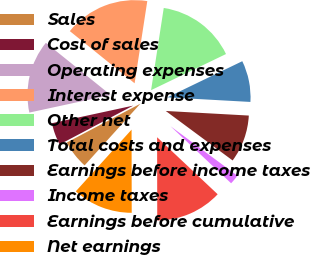<chart> <loc_0><loc_0><loc_500><loc_500><pie_chart><fcel>Sales<fcel>Cost of sales<fcel>Operating expenses<fcel>Interest expense<fcel>Other net<fcel>Total costs and expenses<fcel>Earnings before income taxes<fcel>Income taxes<fcel>Earnings before cumulative<fcel>Net earnings<nl><fcel>5.57%<fcel>4.34%<fcel>14.18%<fcel>16.64%<fcel>15.41%<fcel>8.03%<fcel>9.26%<fcel>1.88%<fcel>12.95%<fcel>11.72%<nl></chart> 